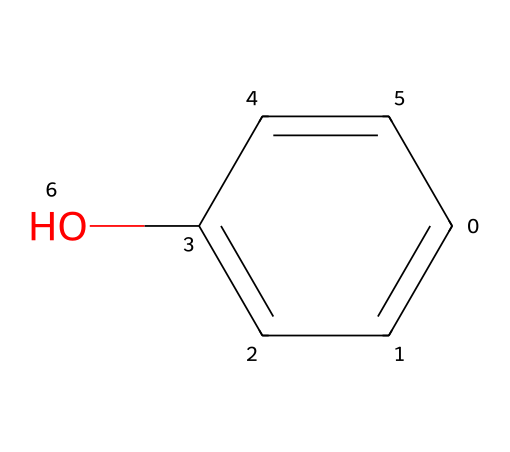What is the primary functional group in this compound? The structural formula shows a hydroxyl group (-OH) attached to the aromatic ring. This functional group is characteristic of alcohols and phenols, indicating that this compound is a phenol.
Answer: hydroxyl How many carbon atoms are present in the structure? By counting the carbon atoms in the aromatic ring, we find six carbon atoms in total, all part of the benzene structure.
Answer: six What type of organic compound is phenol classified as? Phenol contains an aromatic ring and a hydroxyl group, classifying it as an aromatic compound. Specifically, it behaves like an alcohol due to the presence of the hydroxyl group.
Answer: aromatic How many hydrogen atoms are directly bonded to the carbon atoms in phenol? In the structure, there are five hydrogen atoms bonded directly to the carbon atoms in the aromatic ring, as one hydrogen is replaced by the hydroxyl group.
Answer: five Which property of phenols contributes to their effectiveness in disinfectants? The presence of the hydroxyl group enhances the polarity of phenol, allowing it to interact effectively with microbial membranes. This property contributes to its ability as a disinfectant.
Answer: polarity What effect does the hydroxyl group have on the solubility of phenol in water? The hydroxyl group increases the solubility of phenol in water due to hydrogen bonding, making it easier for phenol to dissolve.
Answer: increases What is a common use of phenol in household products? Phenol is frequently used as a disinfectant and antiseptic in cleaning products and personal care items due to its antimicrobial properties.
Answer: disinfectant 